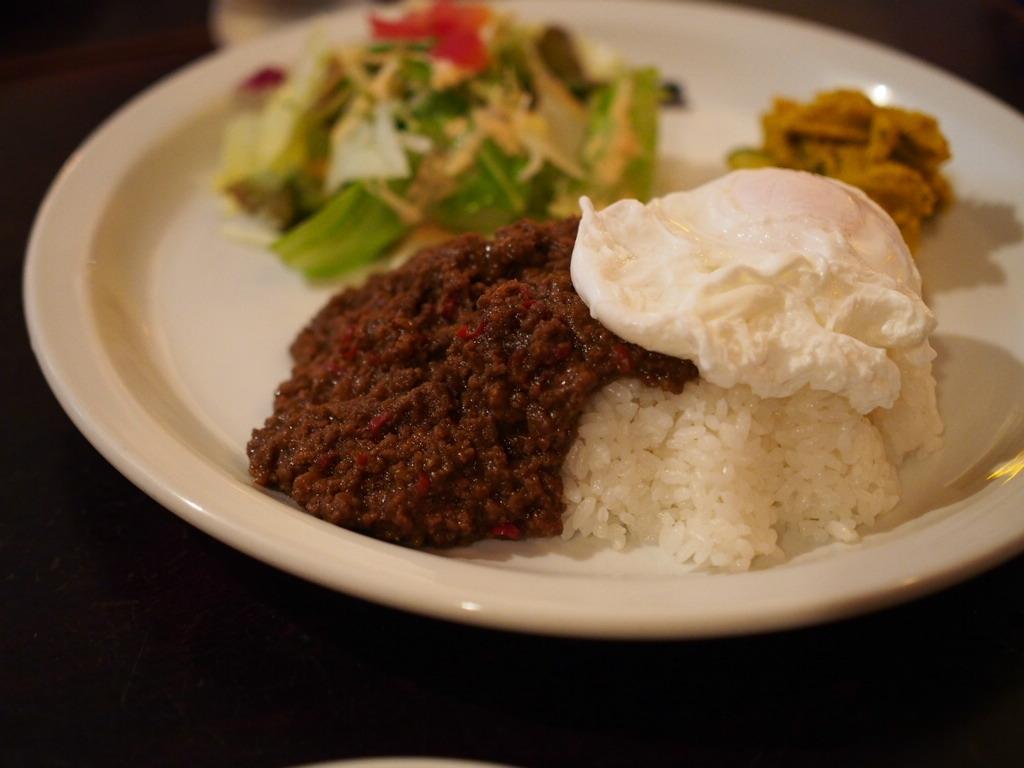Describe this image in one or two sentences. In this image I can see a food in the white plate. Food is in brown,white,green,orange and red color. Background is black in color. 